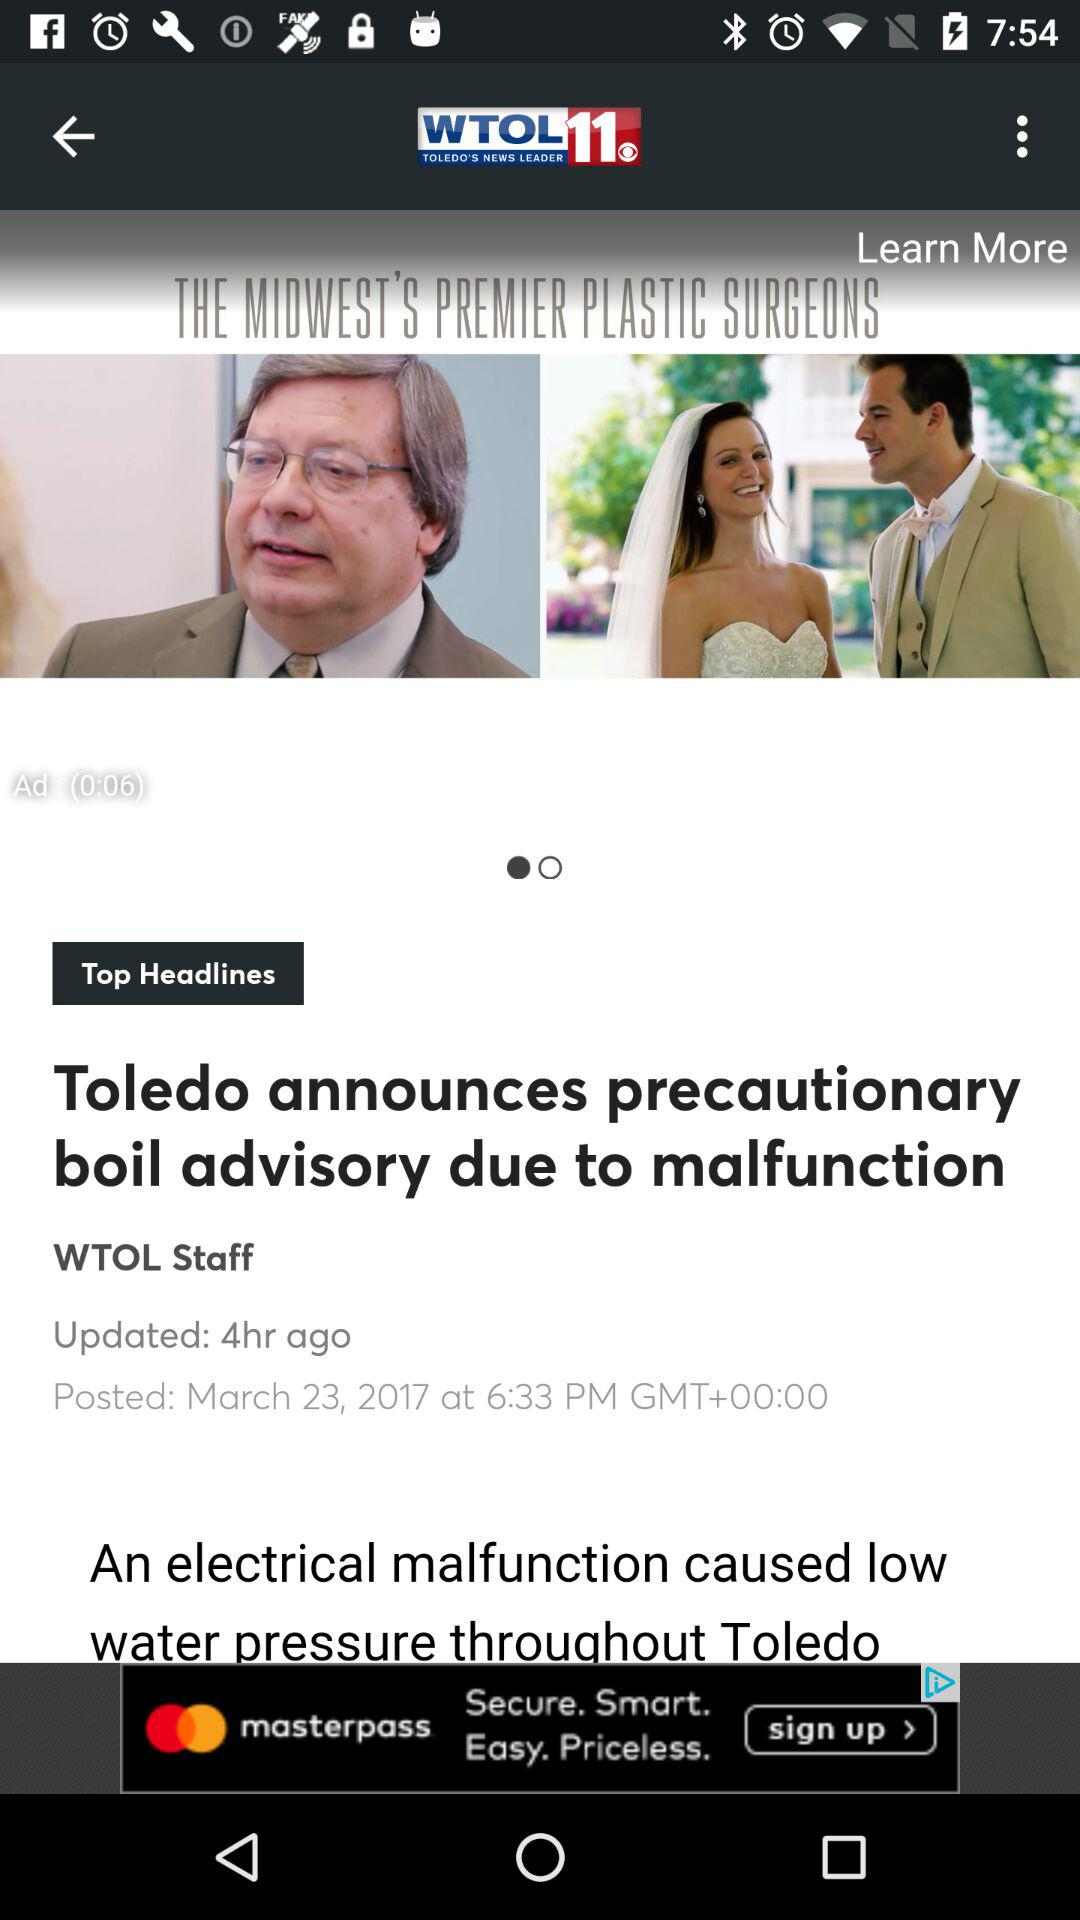When was the news "Toledo announces precautionary boil advisory due to malfunction" published? The news was posted on March 23, 2017 at 6:33 PM. 